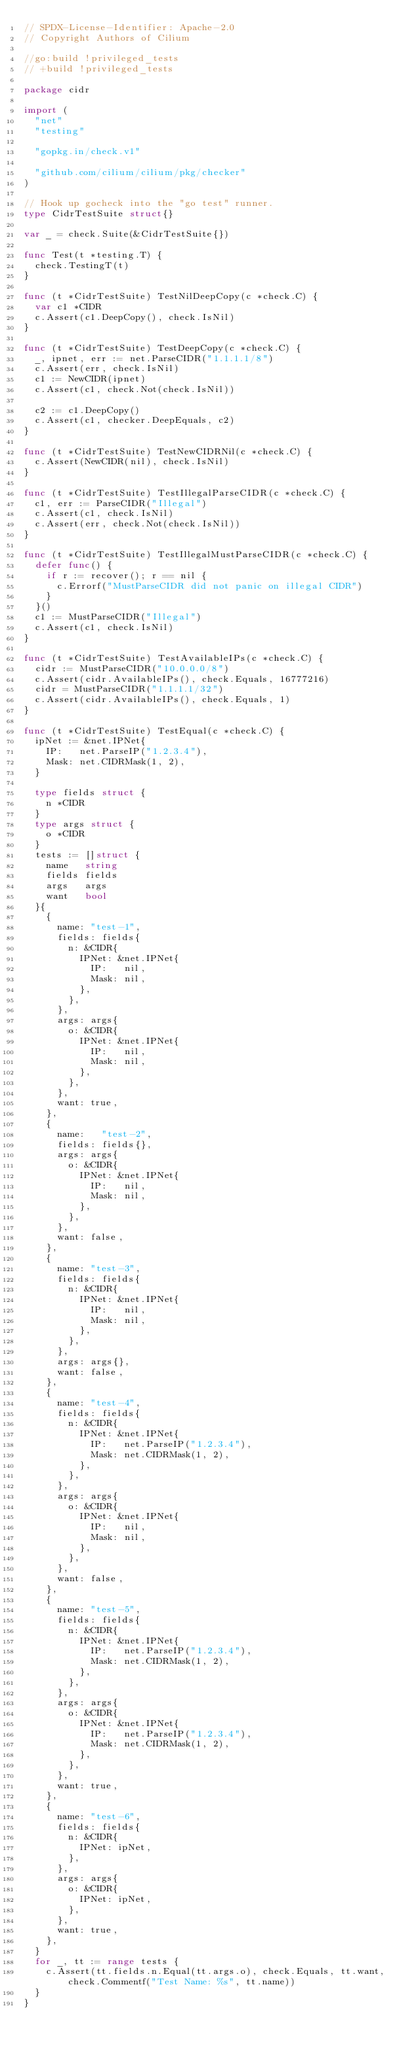Convert code to text. <code><loc_0><loc_0><loc_500><loc_500><_Go_>// SPDX-License-Identifier: Apache-2.0
// Copyright Authors of Cilium

//go:build !privileged_tests
// +build !privileged_tests

package cidr

import (
	"net"
	"testing"

	"gopkg.in/check.v1"

	"github.com/cilium/cilium/pkg/checker"
)

// Hook up gocheck into the "go test" runner.
type CidrTestSuite struct{}

var _ = check.Suite(&CidrTestSuite{})

func Test(t *testing.T) {
	check.TestingT(t)
}

func (t *CidrTestSuite) TestNilDeepCopy(c *check.C) {
	var c1 *CIDR
	c.Assert(c1.DeepCopy(), check.IsNil)
}

func (t *CidrTestSuite) TestDeepCopy(c *check.C) {
	_, ipnet, err := net.ParseCIDR("1.1.1.1/8")
	c.Assert(err, check.IsNil)
	c1 := NewCIDR(ipnet)
	c.Assert(c1, check.Not(check.IsNil))

	c2 := c1.DeepCopy()
	c.Assert(c1, checker.DeepEquals, c2)
}

func (t *CidrTestSuite) TestNewCIDRNil(c *check.C) {
	c.Assert(NewCIDR(nil), check.IsNil)
}

func (t *CidrTestSuite) TestIllegalParseCIDR(c *check.C) {
	c1, err := ParseCIDR("Illegal")
	c.Assert(c1, check.IsNil)
	c.Assert(err, check.Not(check.IsNil))
}

func (t *CidrTestSuite) TestIllegalMustParseCIDR(c *check.C) {
	defer func() {
		if r := recover(); r == nil {
			c.Errorf("MustParseCIDR did not panic on illegal CIDR")
		}
	}()
	c1 := MustParseCIDR("Illegal")
	c.Assert(c1, check.IsNil)
}

func (t *CidrTestSuite) TestAvailableIPs(c *check.C) {
	cidr := MustParseCIDR("10.0.0.0/8")
	c.Assert(cidr.AvailableIPs(), check.Equals, 16777216)
	cidr = MustParseCIDR("1.1.1.1/32")
	c.Assert(cidr.AvailableIPs(), check.Equals, 1)
}

func (t *CidrTestSuite) TestEqual(c *check.C) {
	ipNet := &net.IPNet{
		IP:   net.ParseIP("1.2.3.4"),
		Mask: net.CIDRMask(1, 2),
	}

	type fields struct {
		n *CIDR
	}
	type args struct {
		o *CIDR
	}
	tests := []struct {
		name   string
		fields fields
		args   args
		want   bool
	}{
		{
			name: "test-1",
			fields: fields{
				n: &CIDR{
					IPNet: &net.IPNet{
						IP:   nil,
						Mask: nil,
					},
				},
			},
			args: args{
				o: &CIDR{
					IPNet: &net.IPNet{
						IP:   nil,
						Mask: nil,
					},
				},
			},
			want: true,
		},
		{
			name:   "test-2",
			fields: fields{},
			args: args{
				o: &CIDR{
					IPNet: &net.IPNet{
						IP:   nil,
						Mask: nil,
					},
				},
			},
			want: false,
		},
		{
			name: "test-3",
			fields: fields{
				n: &CIDR{
					IPNet: &net.IPNet{
						IP:   nil,
						Mask: nil,
					},
				},
			},
			args: args{},
			want: false,
		},
		{
			name: "test-4",
			fields: fields{
				n: &CIDR{
					IPNet: &net.IPNet{
						IP:   net.ParseIP("1.2.3.4"),
						Mask: net.CIDRMask(1, 2),
					},
				},
			},
			args: args{
				o: &CIDR{
					IPNet: &net.IPNet{
						IP:   nil,
						Mask: nil,
					},
				},
			},
			want: false,
		},
		{
			name: "test-5",
			fields: fields{
				n: &CIDR{
					IPNet: &net.IPNet{
						IP:   net.ParseIP("1.2.3.4"),
						Mask: net.CIDRMask(1, 2),
					},
				},
			},
			args: args{
				o: &CIDR{
					IPNet: &net.IPNet{
						IP:   net.ParseIP("1.2.3.4"),
						Mask: net.CIDRMask(1, 2),
					},
				},
			},
			want: true,
		},
		{
			name: "test-6",
			fields: fields{
				n: &CIDR{
					IPNet: ipNet,
				},
			},
			args: args{
				o: &CIDR{
					IPNet: ipNet,
				},
			},
			want: true,
		},
	}
	for _, tt := range tests {
		c.Assert(tt.fields.n.Equal(tt.args.o), check.Equals, tt.want, check.Commentf("Test Name: %s", tt.name))
	}
}
</code> 